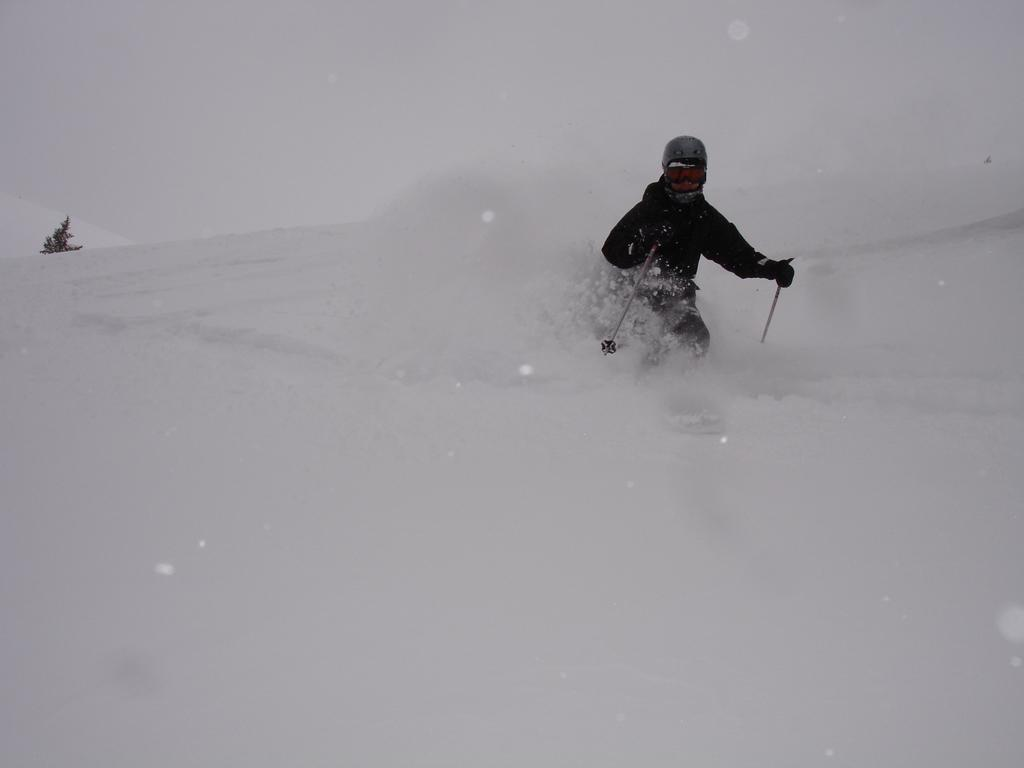Who is in the image? There is a person in the image. What is the person wearing? The person is wearing ski boards. What is the person holding? The person is holding ski sticks. What activity is the person engaged in? The person is skating on the snow. What is the color of the background in the image? The background of the image is white. What type of juice is the person drinking in the image? There is no juice present in the image; the person is skiing on the snow. How many mice can be seen running around the person in the image? There are no mice present in the image; it features a person skiing on the snow. 